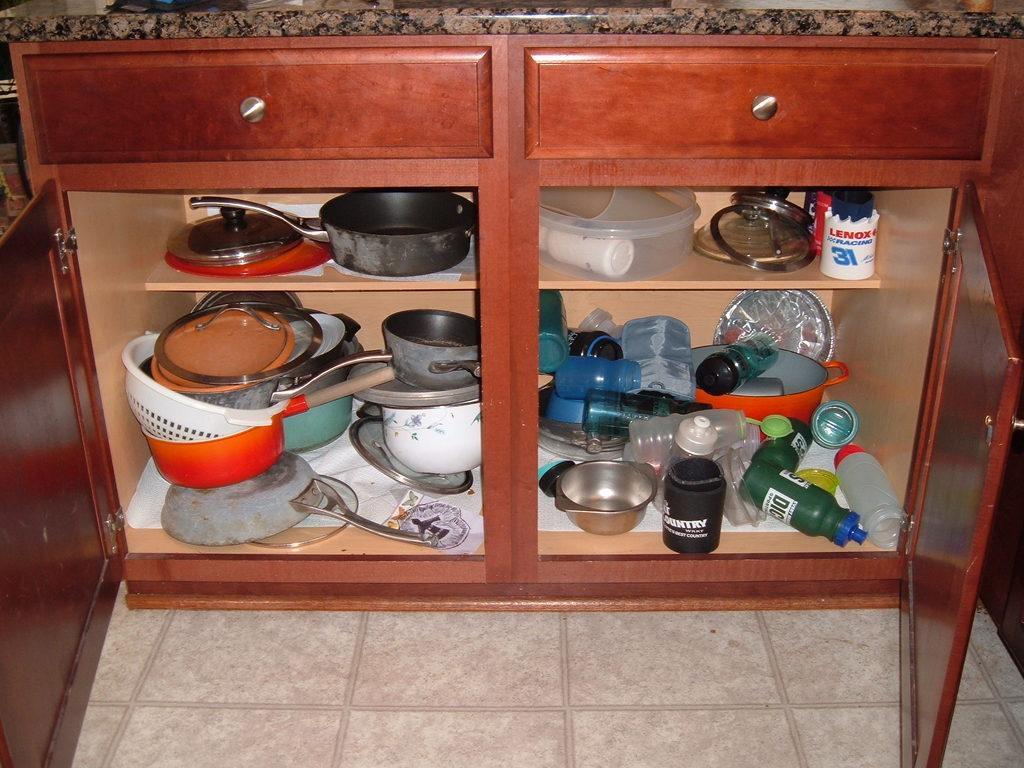Could you give a brief overview of what you see in this image? In this image we can see there is a marble. At the bottom there is a cupboard, in that there are bottles, pan, bowl, box, paper, plates and a few objects. 